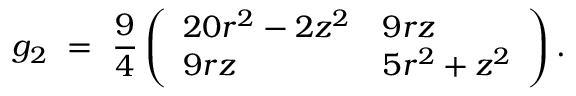Convert formula to latex. <formula><loc_0><loc_0><loc_500><loc_500>g _ { 2 } \ = \ \frac { 9 } { 4 } \left ( \begin{array} { l l } { 2 0 r ^ { 2 } - 2 z ^ { 2 } } & { 9 r z } \\ { 9 r z } & { 5 r ^ { 2 } + z ^ { 2 } } \end{array} \right ) .</formula> 